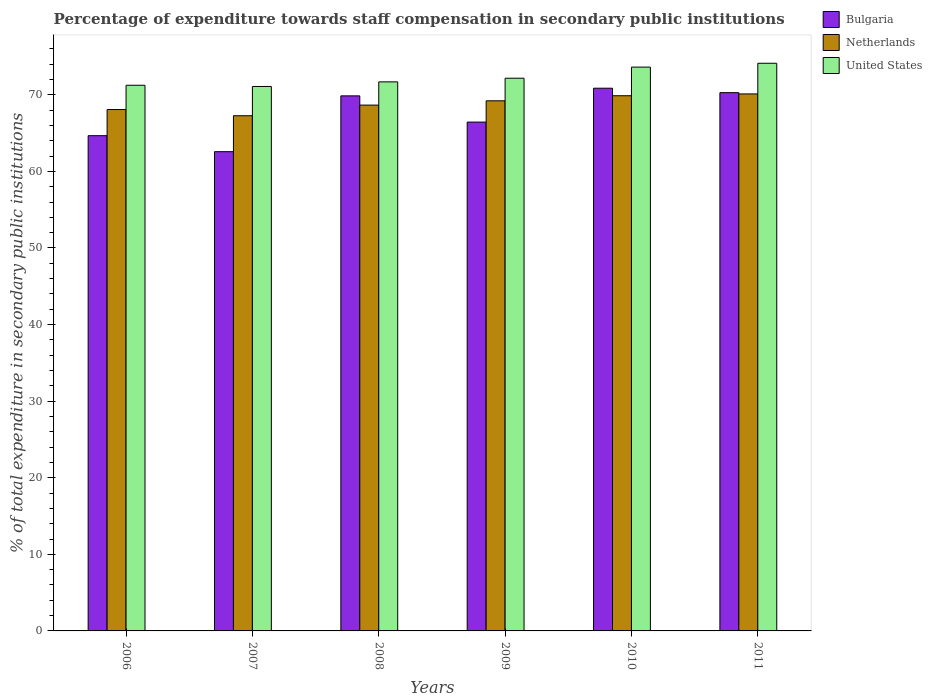How many different coloured bars are there?
Your answer should be compact. 3. How many groups of bars are there?
Give a very brief answer. 6. How many bars are there on the 6th tick from the left?
Provide a short and direct response. 3. What is the label of the 1st group of bars from the left?
Your answer should be very brief. 2006. What is the percentage of expenditure towards staff compensation in Netherlands in 2007?
Offer a very short reply. 67.27. Across all years, what is the maximum percentage of expenditure towards staff compensation in United States?
Provide a short and direct response. 74.12. Across all years, what is the minimum percentage of expenditure towards staff compensation in Bulgaria?
Offer a terse response. 62.57. In which year was the percentage of expenditure towards staff compensation in United States maximum?
Offer a very short reply. 2011. What is the total percentage of expenditure towards staff compensation in United States in the graph?
Give a very brief answer. 433.92. What is the difference between the percentage of expenditure towards staff compensation in Netherlands in 2009 and that in 2011?
Ensure brevity in your answer.  -0.9. What is the difference between the percentage of expenditure towards staff compensation in United States in 2008 and the percentage of expenditure towards staff compensation in Bulgaria in 2007?
Your answer should be very brief. 9.11. What is the average percentage of expenditure towards staff compensation in Bulgaria per year?
Your answer should be very brief. 67.45. In the year 2011, what is the difference between the percentage of expenditure towards staff compensation in Bulgaria and percentage of expenditure towards staff compensation in Netherlands?
Provide a succinct answer. 0.16. In how many years, is the percentage of expenditure towards staff compensation in Bulgaria greater than 16 %?
Keep it short and to the point. 6. What is the ratio of the percentage of expenditure towards staff compensation in United States in 2006 to that in 2007?
Provide a short and direct response. 1. Is the percentage of expenditure towards staff compensation in Netherlands in 2006 less than that in 2008?
Your answer should be compact. Yes. What is the difference between the highest and the second highest percentage of expenditure towards staff compensation in Bulgaria?
Give a very brief answer. 0.58. What is the difference between the highest and the lowest percentage of expenditure towards staff compensation in United States?
Your answer should be very brief. 3.03. In how many years, is the percentage of expenditure towards staff compensation in United States greater than the average percentage of expenditure towards staff compensation in United States taken over all years?
Your answer should be compact. 2. Is the sum of the percentage of expenditure towards staff compensation in Bulgaria in 2006 and 2008 greater than the maximum percentage of expenditure towards staff compensation in Netherlands across all years?
Give a very brief answer. Yes. What does the 2nd bar from the right in 2009 represents?
Your answer should be compact. Netherlands. What is the difference between two consecutive major ticks on the Y-axis?
Make the answer very short. 10. Does the graph contain grids?
Your answer should be very brief. No. Where does the legend appear in the graph?
Offer a very short reply. Top right. How many legend labels are there?
Your answer should be compact. 3. How are the legend labels stacked?
Offer a very short reply. Vertical. What is the title of the graph?
Ensure brevity in your answer.  Percentage of expenditure towards staff compensation in secondary public institutions. Does "Eritrea" appear as one of the legend labels in the graph?
Your response must be concise. No. What is the label or title of the Y-axis?
Your answer should be compact. % of total expenditure in secondary public institutions. What is the % of total expenditure in secondary public institutions in Bulgaria in 2006?
Keep it short and to the point. 64.66. What is the % of total expenditure in secondary public institutions in Netherlands in 2006?
Your response must be concise. 68.08. What is the % of total expenditure in secondary public institutions in United States in 2006?
Your response must be concise. 71.25. What is the % of total expenditure in secondary public institutions of Bulgaria in 2007?
Offer a very short reply. 62.57. What is the % of total expenditure in secondary public institutions of Netherlands in 2007?
Provide a short and direct response. 67.27. What is the % of total expenditure in secondary public institutions in United States in 2007?
Offer a terse response. 71.09. What is the % of total expenditure in secondary public institutions of Bulgaria in 2008?
Give a very brief answer. 69.86. What is the % of total expenditure in secondary public institutions of Netherlands in 2008?
Provide a succinct answer. 68.66. What is the % of total expenditure in secondary public institutions in United States in 2008?
Offer a terse response. 71.69. What is the % of total expenditure in secondary public institutions of Bulgaria in 2009?
Ensure brevity in your answer.  66.44. What is the % of total expenditure in secondary public institutions in Netherlands in 2009?
Give a very brief answer. 69.22. What is the % of total expenditure in secondary public institutions in United States in 2009?
Keep it short and to the point. 72.17. What is the % of total expenditure in secondary public institutions of Bulgaria in 2010?
Ensure brevity in your answer.  70.86. What is the % of total expenditure in secondary public institutions of Netherlands in 2010?
Your response must be concise. 69.88. What is the % of total expenditure in secondary public institutions in United States in 2010?
Your answer should be compact. 73.62. What is the % of total expenditure in secondary public institutions of Bulgaria in 2011?
Offer a very short reply. 70.28. What is the % of total expenditure in secondary public institutions of Netherlands in 2011?
Offer a very short reply. 70.11. What is the % of total expenditure in secondary public institutions in United States in 2011?
Offer a very short reply. 74.12. Across all years, what is the maximum % of total expenditure in secondary public institutions in Bulgaria?
Your answer should be very brief. 70.86. Across all years, what is the maximum % of total expenditure in secondary public institutions of Netherlands?
Give a very brief answer. 70.11. Across all years, what is the maximum % of total expenditure in secondary public institutions in United States?
Your response must be concise. 74.12. Across all years, what is the minimum % of total expenditure in secondary public institutions of Bulgaria?
Provide a succinct answer. 62.57. Across all years, what is the minimum % of total expenditure in secondary public institutions in Netherlands?
Give a very brief answer. 67.27. Across all years, what is the minimum % of total expenditure in secondary public institutions of United States?
Offer a terse response. 71.09. What is the total % of total expenditure in secondary public institutions in Bulgaria in the graph?
Offer a very short reply. 404.68. What is the total % of total expenditure in secondary public institutions in Netherlands in the graph?
Make the answer very short. 413.21. What is the total % of total expenditure in secondary public institutions in United States in the graph?
Your answer should be very brief. 433.92. What is the difference between the % of total expenditure in secondary public institutions in Bulgaria in 2006 and that in 2007?
Ensure brevity in your answer.  2.09. What is the difference between the % of total expenditure in secondary public institutions in Netherlands in 2006 and that in 2007?
Your answer should be very brief. 0.81. What is the difference between the % of total expenditure in secondary public institutions in United States in 2006 and that in 2007?
Give a very brief answer. 0.16. What is the difference between the % of total expenditure in secondary public institutions in Bulgaria in 2006 and that in 2008?
Make the answer very short. -5.2. What is the difference between the % of total expenditure in secondary public institutions in Netherlands in 2006 and that in 2008?
Keep it short and to the point. -0.58. What is the difference between the % of total expenditure in secondary public institutions in United States in 2006 and that in 2008?
Keep it short and to the point. -0.44. What is the difference between the % of total expenditure in secondary public institutions in Bulgaria in 2006 and that in 2009?
Your response must be concise. -1.78. What is the difference between the % of total expenditure in secondary public institutions of Netherlands in 2006 and that in 2009?
Provide a short and direct response. -1.14. What is the difference between the % of total expenditure in secondary public institutions of United States in 2006 and that in 2009?
Your answer should be compact. -0.92. What is the difference between the % of total expenditure in secondary public institutions of Bulgaria in 2006 and that in 2010?
Your response must be concise. -6.2. What is the difference between the % of total expenditure in secondary public institutions of Netherlands in 2006 and that in 2010?
Ensure brevity in your answer.  -1.8. What is the difference between the % of total expenditure in secondary public institutions of United States in 2006 and that in 2010?
Your answer should be compact. -2.37. What is the difference between the % of total expenditure in secondary public institutions of Bulgaria in 2006 and that in 2011?
Your response must be concise. -5.62. What is the difference between the % of total expenditure in secondary public institutions in Netherlands in 2006 and that in 2011?
Make the answer very short. -2.04. What is the difference between the % of total expenditure in secondary public institutions of United States in 2006 and that in 2011?
Your answer should be compact. -2.87. What is the difference between the % of total expenditure in secondary public institutions of Bulgaria in 2007 and that in 2008?
Provide a short and direct response. -7.29. What is the difference between the % of total expenditure in secondary public institutions in Netherlands in 2007 and that in 2008?
Keep it short and to the point. -1.39. What is the difference between the % of total expenditure in secondary public institutions of United States in 2007 and that in 2008?
Ensure brevity in your answer.  -0.6. What is the difference between the % of total expenditure in secondary public institutions of Bulgaria in 2007 and that in 2009?
Ensure brevity in your answer.  -3.87. What is the difference between the % of total expenditure in secondary public institutions of Netherlands in 2007 and that in 2009?
Make the answer very short. -1.95. What is the difference between the % of total expenditure in secondary public institutions in United States in 2007 and that in 2009?
Your answer should be very brief. -1.08. What is the difference between the % of total expenditure in secondary public institutions in Bulgaria in 2007 and that in 2010?
Make the answer very short. -8.29. What is the difference between the % of total expenditure in secondary public institutions in Netherlands in 2007 and that in 2010?
Your response must be concise. -2.61. What is the difference between the % of total expenditure in secondary public institutions of United States in 2007 and that in 2010?
Provide a succinct answer. -2.53. What is the difference between the % of total expenditure in secondary public institutions in Bulgaria in 2007 and that in 2011?
Provide a short and direct response. -7.71. What is the difference between the % of total expenditure in secondary public institutions of Netherlands in 2007 and that in 2011?
Provide a succinct answer. -2.85. What is the difference between the % of total expenditure in secondary public institutions in United States in 2007 and that in 2011?
Give a very brief answer. -3.03. What is the difference between the % of total expenditure in secondary public institutions in Bulgaria in 2008 and that in 2009?
Your answer should be compact. 3.42. What is the difference between the % of total expenditure in secondary public institutions in Netherlands in 2008 and that in 2009?
Your answer should be compact. -0.56. What is the difference between the % of total expenditure in secondary public institutions in United States in 2008 and that in 2009?
Offer a terse response. -0.48. What is the difference between the % of total expenditure in secondary public institutions in Bulgaria in 2008 and that in 2010?
Offer a terse response. -1. What is the difference between the % of total expenditure in secondary public institutions of Netherlands in 2008 and that in 2010?
Offer a very short reply. -1.22. What is the difference between the % of total expenditure in secondary public institutions in United States in 2008 and that in 2010?
Give a very brief answer. -1.93. What is the difference between the % of total expenditure in secondary public institutions in Bulgaria in 2008 and that in 2011?
Offer a very short reply. -0.42. What is the difference between the % of total expenditure in secondary public institutions of Netherlands in 2008 and that in 2011?
Your answer should be compact. -1.46. What is the difference between the % of total expenditure in secondary public institutions of United States in 2008 and that in 2011?
Ensure brevity in your answer.  -2.43. What is the difference between the % of total expenditure in secondary public institutions in Bulgaria in 2009 and that in 2010?
Provide a short and direct response. -4.42. What is the difference between the % of total expenditure in secondary public institutions of Netherlands in 2009 and that in 2010?
Your response must be concise. -0.66. What is the difference between the % of total expenditure in secondary public institutions in United States in 2009 and that in 2010?
Make the answer very short. -1.45. What is the difference between the % of total expenditure in secondary public institutions in Bulgaria in 2009 and that in 2011?
Your response must be concise. -3.84. What is the difference between the % of total expenditure in secondary public institutions of Netherlands in 2009 and that in 2011?
Your answer should be compact. -0.9. What is the difference between the % of total expenditure in secondary public institutions of United States in 2009 and that in 2011?
Make the answer very short. -1.95. What is the difference between the % of total expenditure in secondary public institutions of Bulgaria in 2010 and that in 2011?
Your response must be concise. 0.58. What is the difference between the % of total expenditure in secondary public institutions in Netherlands in 2010 and that in 2011?
Your response must be concise. -0.24. What is the difference between the % of total expenditure in secondary public institutions of United States in 2010 and that in 2011?
Your answer should be compact. -0.5. What is the difference between the % of total expenditure in secondary public institutions in Bulgaria in 2006 and the % of total expenditure in secondary public institutions in Netherlands in 2007?
Your response must be concise. -2.6. What is the difference between the % of total expenditure in secondary public institutions in Bulgaria in 2006 and the % of total expenditure in secondary public institutions in United States in 2007?
Your response must be concise. -6.43. What is the difference between the % of total expenditure in secondary public institutions of Netherlands in 2006 and the % of total expenditure in secondary public institutions of United States in 2007?
Provide a short and direct response. -3.01. What is the difference between the % of total expenditure in secondary public institutions in Bulgaria in 2006 and the % of total expenditure in secondary public institutions in Netherlands in 2008?
Offer a terse response. -3.99. What is the difference between the % of total expenditure in secondary public institutions in Bulgaria in 2006 and the % of total expenditure in secondary public institutions in United States in 2008?
Offer a very short reply. -7.03. What is the difference between the % of total expenditure in secondary public institutions in Netherlands in 2006 and the % of total expenditure in secondary public institutions in United States in 2008?
Your answer should be very brief. -3.61. What is the difference between the % of total expenditure in secondary public institutions in Bulgaria in 2006 and the % of total expenditure in secondary public institutions in Netherlands in 2009?
Offer a very short reply. -4.55. What is the difference between the % of total expenditure in secondary public institutions in Bulgaria in 2006 and the % of total expenditure in secondary public institutions in United States in 2009?
Offer a very short reply. -7.5. What is the difference between the % of total expenditure in secondary public institutions in Netherlands in 2006 and the % of total expenditure in secondary public institutions in United States in 2009?
Provide a short and direct response. -4.09. What is the difference between the % of total expenditure in secondary public institutions of Bulgaria in 2006 and the % of total expenditure in secondary public institutions of Netherlands in 2010?
Your answer should be compact. -5.22. What is the difference between the % of total expenditure in secondary public institutions of Bulgaria in 2006 and the % of total expenditure in secondary public institutions of United States in 2010?
Provide a short and direct response. -8.95. What is the difference between the % of total expenditure in secondary public institutions of Netherlands in 2006 and the % of total expenditure in secondary public institutions of United States in 2010?
Make the answer very short. -5.54. What is the difference between the % of total expenditure in secondary public institutions in Bulgaria in 2006 and the % of total expenditure in secondary public institutions in Netherlands in 2011?
Your answer should be compact. -5.45. What is the difference between the % of total expenditure in secondary public institutions in Bulgaria in 2006 and the % of total expenditure in secondary public institutions in United States in 2011?
Ensure brevity in your answer.  -9.46. What is the difference between the % of total expenditure in secondary public institutions of Netherlands in 2006 and the % of total expenditure in secondary public institutions of United States in 2011?
Provide a succinct answer. -6.04. What is the difference between the % of total expenditure in secondary public institutions in Bulgaria in 2007 and the % of total expenditure in secondary public institutions in Netherlands in 2008?
Provide a succinct answer. -6.08. What is the difference between the % of total expenditure in secondary public institutions in Bulgaria in 2007 and the % of total expenditure in secondary public institutions in United States in 2008?
Ensure brevity in your answer.  -9.12. What is the difference between the % of total expenditure in secondary public institutions in Netherlands in 2007 and the % of total expenditure in secondary public institutions in United States in 2008?
Keep it short and to the point. -4.42. What is the difference between the % of total expenditure in secondary public institutions in Bulgaria in 2007 and the % of total expenditure in secondary public institutions in Netherlands in 2009?
Provide a succinct answer. -6.64. What is the difference between the % of total expenditure in secondary public institutions in Bulgaria in 2007 and the % of total expenditure in secondary public institutions in United States in 2009?
Ensure brevity in your answer.  -9.59. What is the difference between the % of total expenditure in secondary public institutions of Netherlands in 2007 and the % of total expenditure in secondary public institutions of United States in 2009?
Give a very brief answer. -4.9. What is the difference between the % of total expenditure in secondary public institutions of Bulgaria in 2007 and the % of total expenditure in secondary public institutions of Netherlands in 2010?
Give a very brief answer. -7.3. What is the difference between the % of total expenditure in secondary public institutions in Bulgaria in 2007 and the % of total expenditure in secondary public institutions in United States in 2010?
Keep it short and to the point. -11.04. What is the difference between the % of total expenditure in secondary public institutions of Netherlands in 2007 and the % of total expenditure in secondary public institutions of United States in 2010?
Provide a succinct answer. -6.35. What is the difference between the % of total expenditure in secondary public institutions in Bulgaria in 2007 and the % of total expenditure in secondary public institutions in Netherlands in 2011?
Provide a short and direct response. -7.54. What is the difference between the % of total expenditure in secondary public institutions of Bulgaria in 2007 and the % of total expenditure in secondary public institutions of United States in 2011?
Make the answer very short. -11.55. What is the difference between the % of total expenditure in secondary public institutions in Netherlands in 2007 and the % of total expenditure in secondary public institutions in United States in 2011?
Offer a very short reply. -6.85. What is the difference between the % of total expenditure in secondary public institutions of Bulgaria in 2008 and the % of total expenditure in secondary public institutions of Netherlands in 2009?
Your response must be concise. 0.64. What is the difference between the % of total expenditure in secondary public institutions in Bulgaria in 2008 and the % of total expenditure in secondary public institutions in United States in 2009?
Your answer should be compact. -2.3. What is the difference between the % of total expenditure in secondary public institutions in Netherlands in 2008 and the % of total expenditure in secondary public institutions in United States in 2009?
Your answer should be very brief. -3.51. What is the difference between the % of total expenditure in secondary public institutions in Bulgaria in 2008 and the % of total expenditure in secondary public institutions in Netherlands in 2010?
Offer a very short reply. -0.02. What is the difference between the % of total expenditure in secondary public institutions of Bulgaria in 2008 and the % of total expenditure in secondary public institutions of United States in 2010?
Ensure brevity in your answer.  -3.75. What is the difference between the % of total expenditure in secondary public institutions in Netherlands in 2008 and the % of total expenditure in secondary public institutions in United States in 2010?
Keep it short and to the point. -4.96. What is the difference between the % of total expenditure in secondary public institutions in Bulgaria in 2008 and the % of total expenditure in secondary public institutions in Netherlands in 2011?
Provide a short and direct response. -0.25. What is the difference between the % of total expenditure in secondary public institutions in Bulgaria in 2008 and the % of total expenditure in secondary public institutions in United States in 2011?
Give a very brief answer. -4.26. What is the difference between the % of total expenditure in secondary public institutions of Netherlands in 2008 and the % of total expenditure in secondary public institutions of United States in 2011?
Keep it short and to the point. -5.46. What is the difference between the % of total expenditure in secondary public institutions of Bulgaria in 2009 and the % of total expenditure in secondary public institutions of Netherlands in 2010?
Your answer should be compact. -3.44. What is the difference between the % of total expenditure in secondary public institutions of Bulgaria in 2009 and the % of total expenditure in secondary public institutions of United States in 2010?
Your answer should be very brief. -7.18. What is the difference between the % of total expenditure in secondary public institutions of Netherlands in 2009 and the % of total expenditure in secondary public institutions of United States in 2010?
Ensure brevity in your answer.  -4.4. What is the difference between the % of total expenditure in secondary public institutions of Bulgaria in 2009 and the % of total expenditure in secondary public institutions of Netherlands in 2011?
Offer a terse response. -3.68. What is the difference between the % of total expenditure in secondary public institutions in Bulgaria in 2009 and the % of total expenditure in secondary public institutions in United States in 2011?
Your answer should be compact. -7.68. What is the difference between the % of total expenditure in secondary public institutions of Netherlands in 2009 and the % of total expenditure in secondary public institutions of United States in 2011?
Provide a succinct answer. -4.9. What is the difference between the % of total expenditure in secondary public institutions in Bulgaria in 2010 and the % of total expenditure in secondary public institutions in Netherlands in 2011?
Make the answer very short. 0.75. What is the difference between the % of total expenditure in secondary public institutions of Bulgaria in 2010 and the % of total expenditure in secondary public institutions of United States in 2011?
Offer a very short reply. -3.26. What is the difference between the % of total expenditure in secondary public institutions in Netherlands in 2010 and the % of total expenditure in secondary public institutions in United States in 2011?
Keep it short and to the point. -4.24. What is the average % of total expenditure in secondary public institutions of Bulgaria per year?
Make the answer very short. 67.45. What is the average % of total expenditure in secondary public institutions of Netherlands per year?
Ensure brevity in your answer.  68.87. What is the average % of total expenditure in secondary public institutions in United States per year?
Offer a terse response. 72.32. In the year 2006, what is the difference between the % of total expenditure in secondary public institutions of Bulgaria and % of total expenditure in secondary public institutions of Netherlands?
Give a very brief answer. -3.41. In the year 2006, what is the difference between the % of total expenditure in secondary public institutions in Bulgaria and % of total expenditure in secondary public institutions in United States?
Keep it short and to the point. -6.58. In the year 2006, what is the difference between the % of total expenditure in secondary public institutions of Netherlands and % of total expenditure in secondary public institutions of United States?
Give a very brief answer. -3.17. In the year 2007, what is the difference between the % of total expenditure in secondary public institutions in Bulgaria and % of total expenditure in secondary public institutions in Netherlands?
Provide a short and direct response. -4.69. In the year 2007, what is the difference between the % of total expenditure in secondary public institutions in Bulgaria and % of total expenditure in secondary public institutions in United States?
Ensure brevity in your answer.  -8.51. In the year 2007, what is the difference between the % of total expenditure in secondary public institutions of Netherlands and % of total expenditure in secondary public institutions of United States?
Keep it short and to the point. -3.82. In the year 2008, what is the difference between the % of total expenditure in secondary public institutions in Bulgaria and % of total expenditure in secondary public institutions in Netherlands?
Offer a very short reply. 1.21. In the year 2008, what is the difference between the % of total expenditure in secondary public institutions of Bulgaria and % of total expenditure in secondary public institutions of United States?
Give a very brief answer. -1.83. In the year 2008, what is the difference between the % of total expenditure in secondary public institutions of Netherlands and % of total expenditure in secondary public institutions of United States?
Make the answer very short. -3.03. In the year 2009, what is the difference between the % of total expenditure in secondary public institutions in Bulgaria and % of total expenditure in secondary public institutions in Netherlands?
Offer a terse response. -2.78. In the year 2009, what is the difference between the % of total expenditure in secondary public institutions in Bulgaria and % of total expenditure in secondary public institutions in United States?
Ensure brevity in your answer.  -5.73. In the year 2009, what is the difference between the % of total expenditure in secondary public institutions of Netherlands and % of total expenditure in secondary public institutions of United States?
Offer a terse response. -2.95. In the year 2010, what is the difference between the % of total expenditure in secondary public institutions in Bulgaria and % of total expenditure in secondary public institutions in Netherlands?
Your response must be concise. 0.98. In the year 2010, what is the difference between the % of total expenditure in secondary public institutions in Bulgaria and % of total expenditure in secondary public institutions in United States?
Offer a very short reply. -2.75. In the year 2010, what is the difference between the % of total expenditure in secondary public institutions of Netherlands and % of total expenditure in secondary public institutions of United States?
Keep it short and to the point. -3.74. In the year 2011, what is the difference between the % of total expenditure in secondary public institutions in Bulgaria and % of total expenditure in secondary public institutions in Netherlands?
Offer a very short reply. 0.16. In the year 2011, what is the difference between the % of total expenditure in secondary public institutions of Bulgaria and % of total expenditure in secondary public institutions of United States?
Your answer should be very brief. -3.84. In the year 2011, what is the difference between the % of total expenditure in secondary public institutions in Netherlands and % of total expenditure in secondary public institutions in United States?
Offer a very short reply. -4. What is the ratio of the % of total expenditure in secondary public institutions of Bulgaria in 2006 to that in 2007?
Give a very brief answer. 1.03. What is the ratio of the % of total expenditure in secondary public institutions in Bulgaria in 2006 to that in 2008?
Offer a very short reply. 0.93. What is the ratio of the % of total expenditure in secondary public institutions in United States in 2006 to that in 2008?
Your answer should be compact. 0.99. What is the ratio of the % of total expenditure in secondary public institutions of Bulgaria in 2006 to that in 2009?
Offer a terse response. 0.97. What is the ratio of the % of total expenditure in secondary public institutions of Netherlands in 2006 to that in 2009?
Ensure brevity in your answer.  0.98. What is the ratio of the % of total expenditure in secondary public institutions in United States in 2006 to that in 2009?
Provide a short and direct response. 0.99. What is the ratio of the % of total expenditure in secondary public institutions of Bulgaria in 2006 to that in 2010?
Make the answer very short. 0.91. What is the ratio of the % of total expenditure in secondary public institutions of Netherlands in 2006 to that in 2010?
Give a very brief answer. 0.97. What is the ratio of the % of total expenditure in secondary public institutions of United States in 2006 to that in 2010?
Give a very brief answer. 0.97. What is the ratio of the % of total expenditure in secondary public institutions of Bulgaria in 2006 to that in 2011?
Provide a succinct answer. 0.92. What is the ratio of the % of total expenditure in secondary public institutions of Netherlands in 2006 to that in 2011?
Provide a short and direct response. 0.97. What is the ratio of the % of total expenditure in secondary public institutions of United States in 2006 to that in 2011?
Your response must be concise. 0.96. What is the ratio of the % of total expenditure in secondary public institutions of Bulgaria in 2007 to that in 2008?
Offer a terse response. 0.9. What is the ratio of the % of total expenditure in secondary public institutions in Netherlands in 2007 to that in 2008?
Offer a terse response. 0.98. What is the ratio of the % of total expenditure in secondary public institutions of Bulgaria in 2007 to that in 2009?
Make the answer very short. 0.94. What is the ratio of the % of total expenditure in secondary public institutions in Netherlands in 2007 to that in 2009?
Your response must be concise. 0.97. What is the ratio of the % of total expenditure in secondary public institutions in United States in 2007 to that in 2009?
Keep it short and to the point. 0.99. What is the ratio of the % of total expenditure in secondary public institutions of Bulgaria in 2007 to that in 2010?
Offer a terse response. 0.88. What is the ratio of the % of total expenditure in secondary public institutions of Netherlands in 2007 to that in 2010?
Make the answer very short. 0.96. What is the ratio of the % of total expenditure in secondary public institutions of United States in 2007 to that in 2010?
Provide a short and direct response. 0.97. What is the ratio of the % of total expenditure in secondary public institutions of Bulgaria in 2007 to that in 2011?
Provide a short and direct response. 0.89. What is the ratio of the % of total expenditure in secondary public institutions of Netherlands in 2007 to that in 2011?
Provide a succinct answer. 0.96. What is the ratio of the % of total expenditure in secondary public institutions of United States in 2007 to that in 2011?
Give a very brief answer. 0.96. What is the ratio of the % of total expenditure in secondary public institutions in Bulgaria in 2008 to that in 2009?
Provide a succinct answer. 1.05. What is the ratio of the % of total expenditure in secondary public institutions in Bulgaria in 2008 to that in 2010?
Your response must be concise. 0.99. What is the ratio of the % of total expenditure in secondary public institutions of Netherlands in 2008 to that in 2010?
Your answer should be compact. 0.98. What is the ratio of the % of total expenditure in secondary public institutions in United States in 2008 to that in 2010?
Your answer should be compact. 0.97. What is the ratio of the % of total expenditure in secondary public institutions of Netherlands in 2008 to that in 2011?
Your response must be concise. 0.98. What is the ratio of the % of total expenditure in secondary public institutions of United States in 2008 to that in 2011?
Offer a very short reply. 0.97. What is the ratio of the % of total expenditure in secondary public institutions in Bulgaria in 2009 to that in 2010?
Your answer should be very brief. 0.94. What is the ratio of the % of total expenditure in secondary public institutions in United States in 2009 to that in 2010?
Offer a terse response. 0.98. What is the ratio of the % of total expenditure in secondary public institutions in Bulgaria in 2009 to that in 2011?
Your answer should be very brief. 0.95. What is the ratio of the % of total expenditure in secondary public institutions of Netherlands in 2009 to that in 2011?
Your answer should be very brief. 0.99. What is the ratio of the % of total expenditure in secondary public institutions in United States in 2009 to that in 2011?
Offer a terse response. 0.97. What is the ratio of the % of total expenditure in secondary public institutions of Bulgaria in 2010 to that in 2011?
Provide a short and direct response. 1.01. What is the ratio of the % of total expenditure in secondary public institutions of Netherlands in 2010 to that in 2011?
Give a very brief answer. 1. What is the difference between the highest and the second highest % of total expenditure in secondary public institutions of Bulgaria?
Your answer should be very brief. 0.58. What is the difference between the highest and the second highest % of total expenditure in secondary public institutions of Netherlands?
Keep it short and to the point. 0.24. What is the difference between the highest and the second highest % of total expenditure in secondary public institutions in United States?
Ensure brevity in your answer.  0.5. What is the difference between the highest and the lowest % of total expenditure in secondary public institutions in Bulgaria?
Offer a very short reply. 8.29. What is the difference between the highest and the lowest % of total expenditure in secondary public institutions in Netherlands?
Offer a very short reply. 2.85. What is the difference between the highest and the lowest % of total expenditure in secondary public institutions in United States?
Offer a terse response. 3.03. 